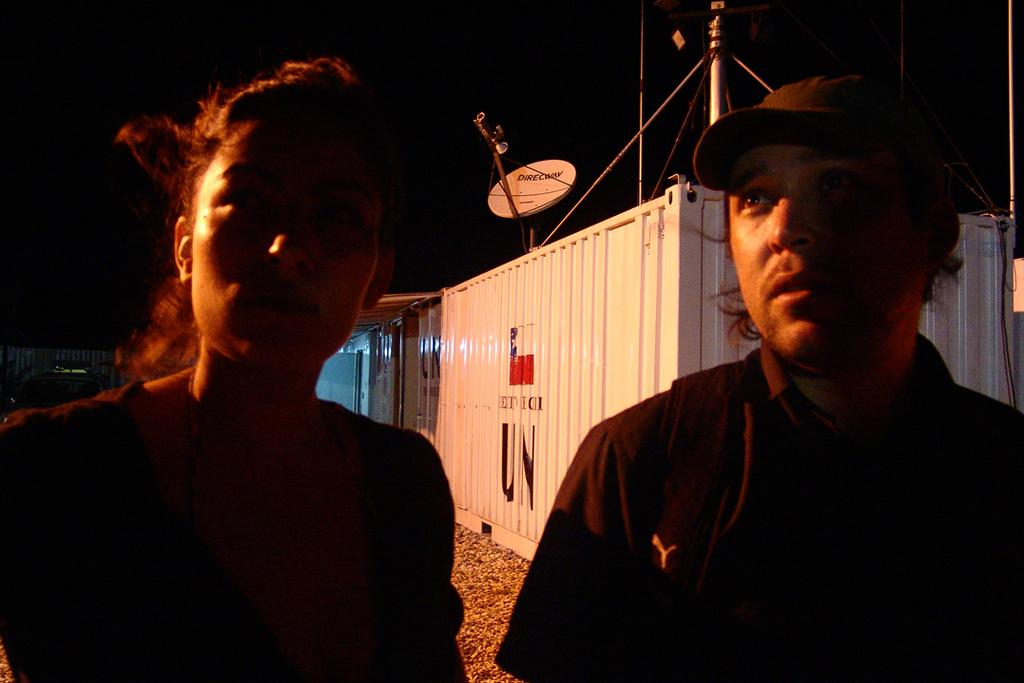How many persons are visible in the foreground of the image? There are two persons on the road in the foreground. What can be seen in the background of the image? In the background, there are metal objects, poles, wires, a fence, vehicles, and the sky. What type of objects are present in the background? The objects in the background include metal objects, poles, wires, a fence, and vehicles. Can you describe the lighting conditions in the image? The image may have been taken during the night, as the lighting appears to be dim. Where is the hole in the image, and what is it used for? There is no hole present in the image. What type of tray can be seen in the image? There is no tray present in the image. 